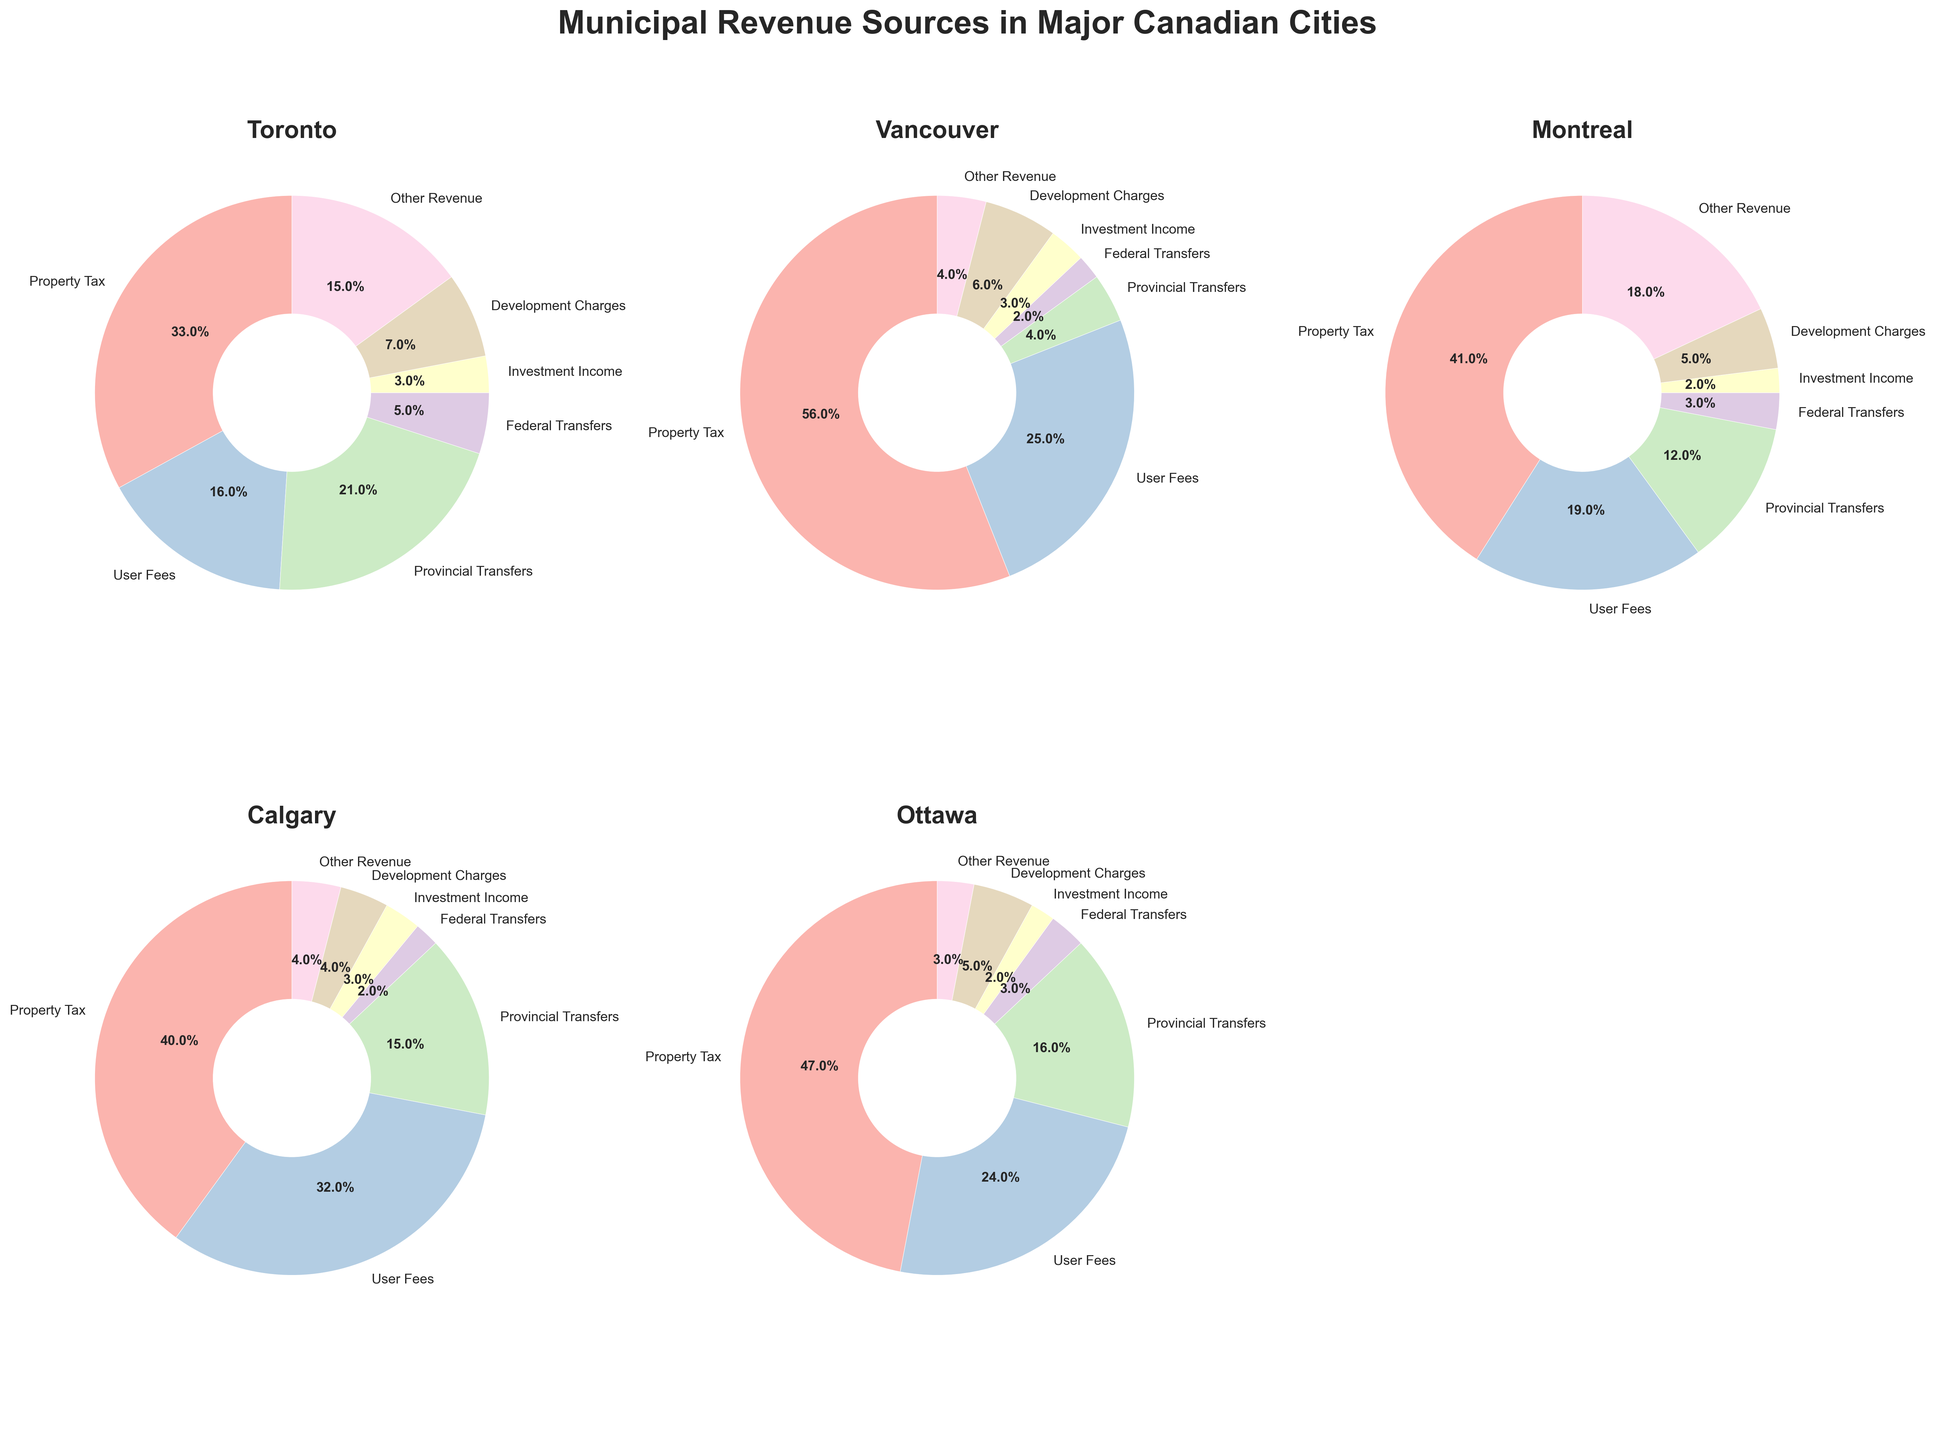Which city relies the most on property tax as a revenue source? To identify which city has the highest reliance on property tax, look at each pie chart and find the sector labeled "Property Tax". In Vancouver's chart, the "Property Tax" segment is the largest at 56%, which is higher than in any other city.
Answer: Vancouver Which city has the least dependency on federal transfers? Check each pie chart for the "Federal Transfers" segment and compare their sizes. Toronto and Calgary both have "Federal Transfers" segments at 2%. The description specifies percentages, so Calgary and Vancouver rely the least on federal transfers.
Answer: Vancouver and Calgary What is the combined percentage of user fees and development charges in Montreal? Find Montreal's pie chart, identify the "User Fees" and "Development Charges" segments, and sum their percentages. User Fees is 19%, and Development Charges is 5%, so 19 + 5 = 24%.
Answer: 24% Which city has the highest percentage of "Other Revenue"? Check the "Other Revenue" segments in each pie chart. Montreal has the highest at 18%, which is more than Vancouver (4%), Calgary (4%), and Toronto (15%).
Answer: Montreal How does Calgary compare to Ottawa in terms of percentage of provincial transfers? Look at the pie charts for Calgary and Ottawa, and find the "Provincial Transfers" segments. Calgary's provincial transfers account for 15%, and Ottawa's for 16%. Therefore, Ottawa's percentage is 1% higher.
Answer: Ottawa is 1% higher Which city has the smallest percentage of revenue from investment income? Identify the "Investment Income" segments for each city and compare them. Both Montreal and Ottawa have the smallest segment at 2%.
Answer: Montreal and Ottawa In which city is the revenue distribution more diversified among the various sources? To find the city with more diversified revenue, compare the varying sizes of the segments. Toronto has a more even spread with Property Tax (33%), User Fees (16%), Provincial Transfers (21%), Federal Transfers (5%), Investment Income (3%), Development Charges (7%), and Other Revenue (15%).
Answer: Toronto What is the difference in percentage points between Toronto's and Vancouver's property tax revenue? Find the "Property Tax" segments in Toronto's and Vancouver's pie charts. Toronto has 33% while Vancouver has 56%. The difference is 56 - 33 = 23 percentage points.
Answer: 23 percentage points 